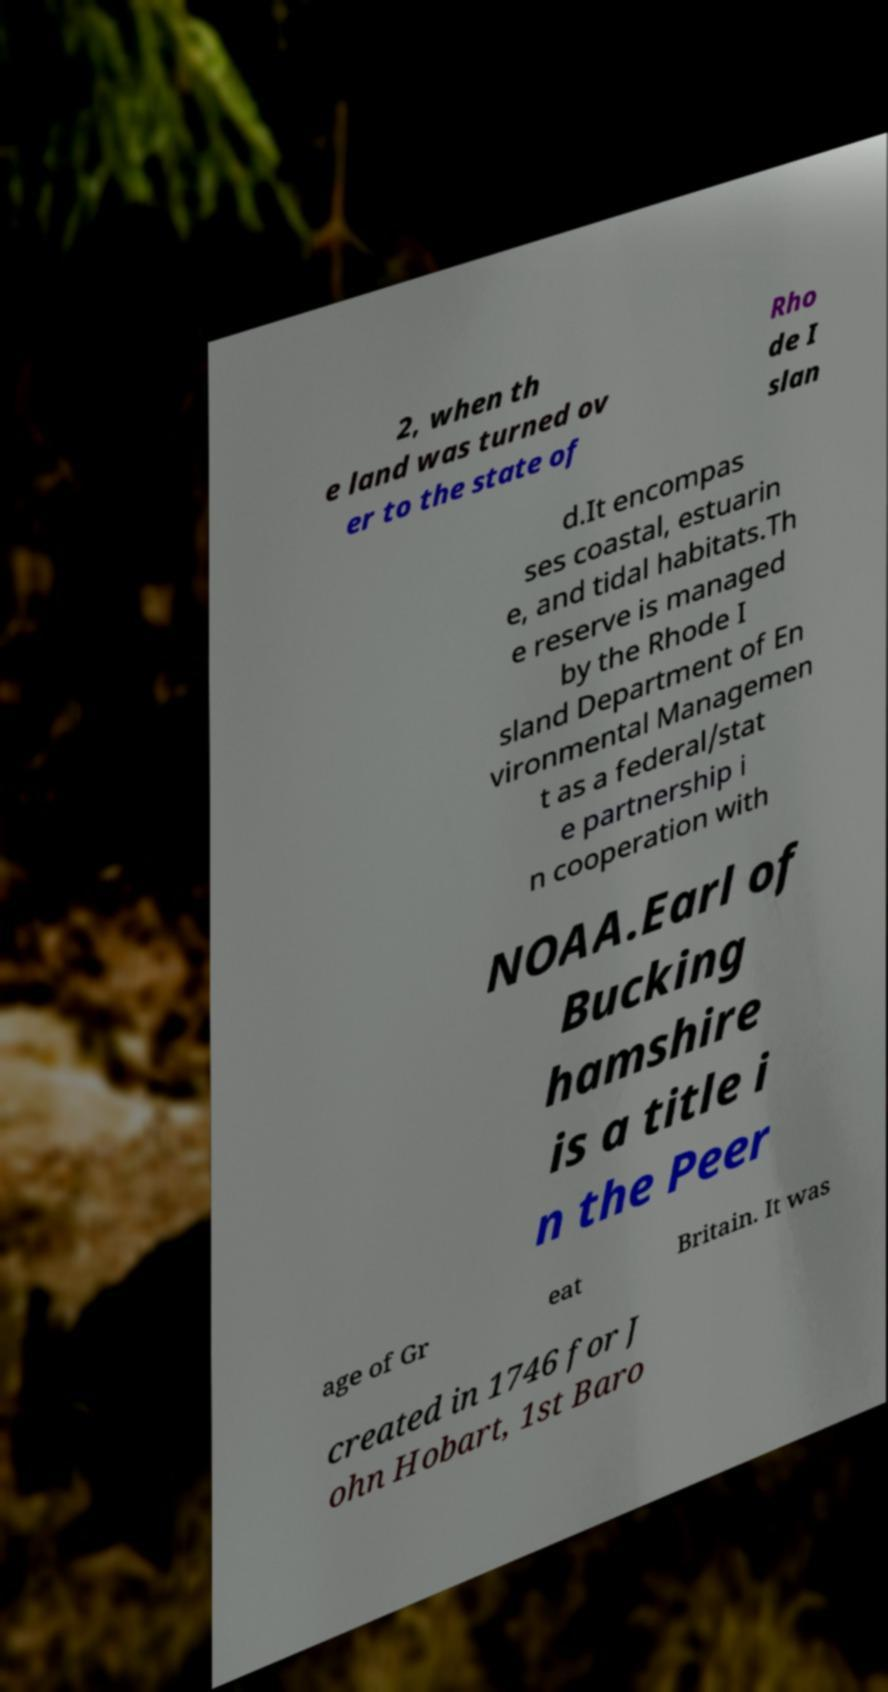Could you extract and type out the text from this image? 2, when th e land was turned ov er to the state of Rho de I slan d.It encompas ses coastal, estuarin e, and tidal habitats.Th e reserve is managed by the Rhode I sland Department of En vironmental Managemen t as a federal/stat e partnership i n cooperation with NOAA.Earl of Bucking hamshire is a title i n the Peer age of Gr eat Britain. It was created in 1746 for J ohn Hobart, 1st Baro 